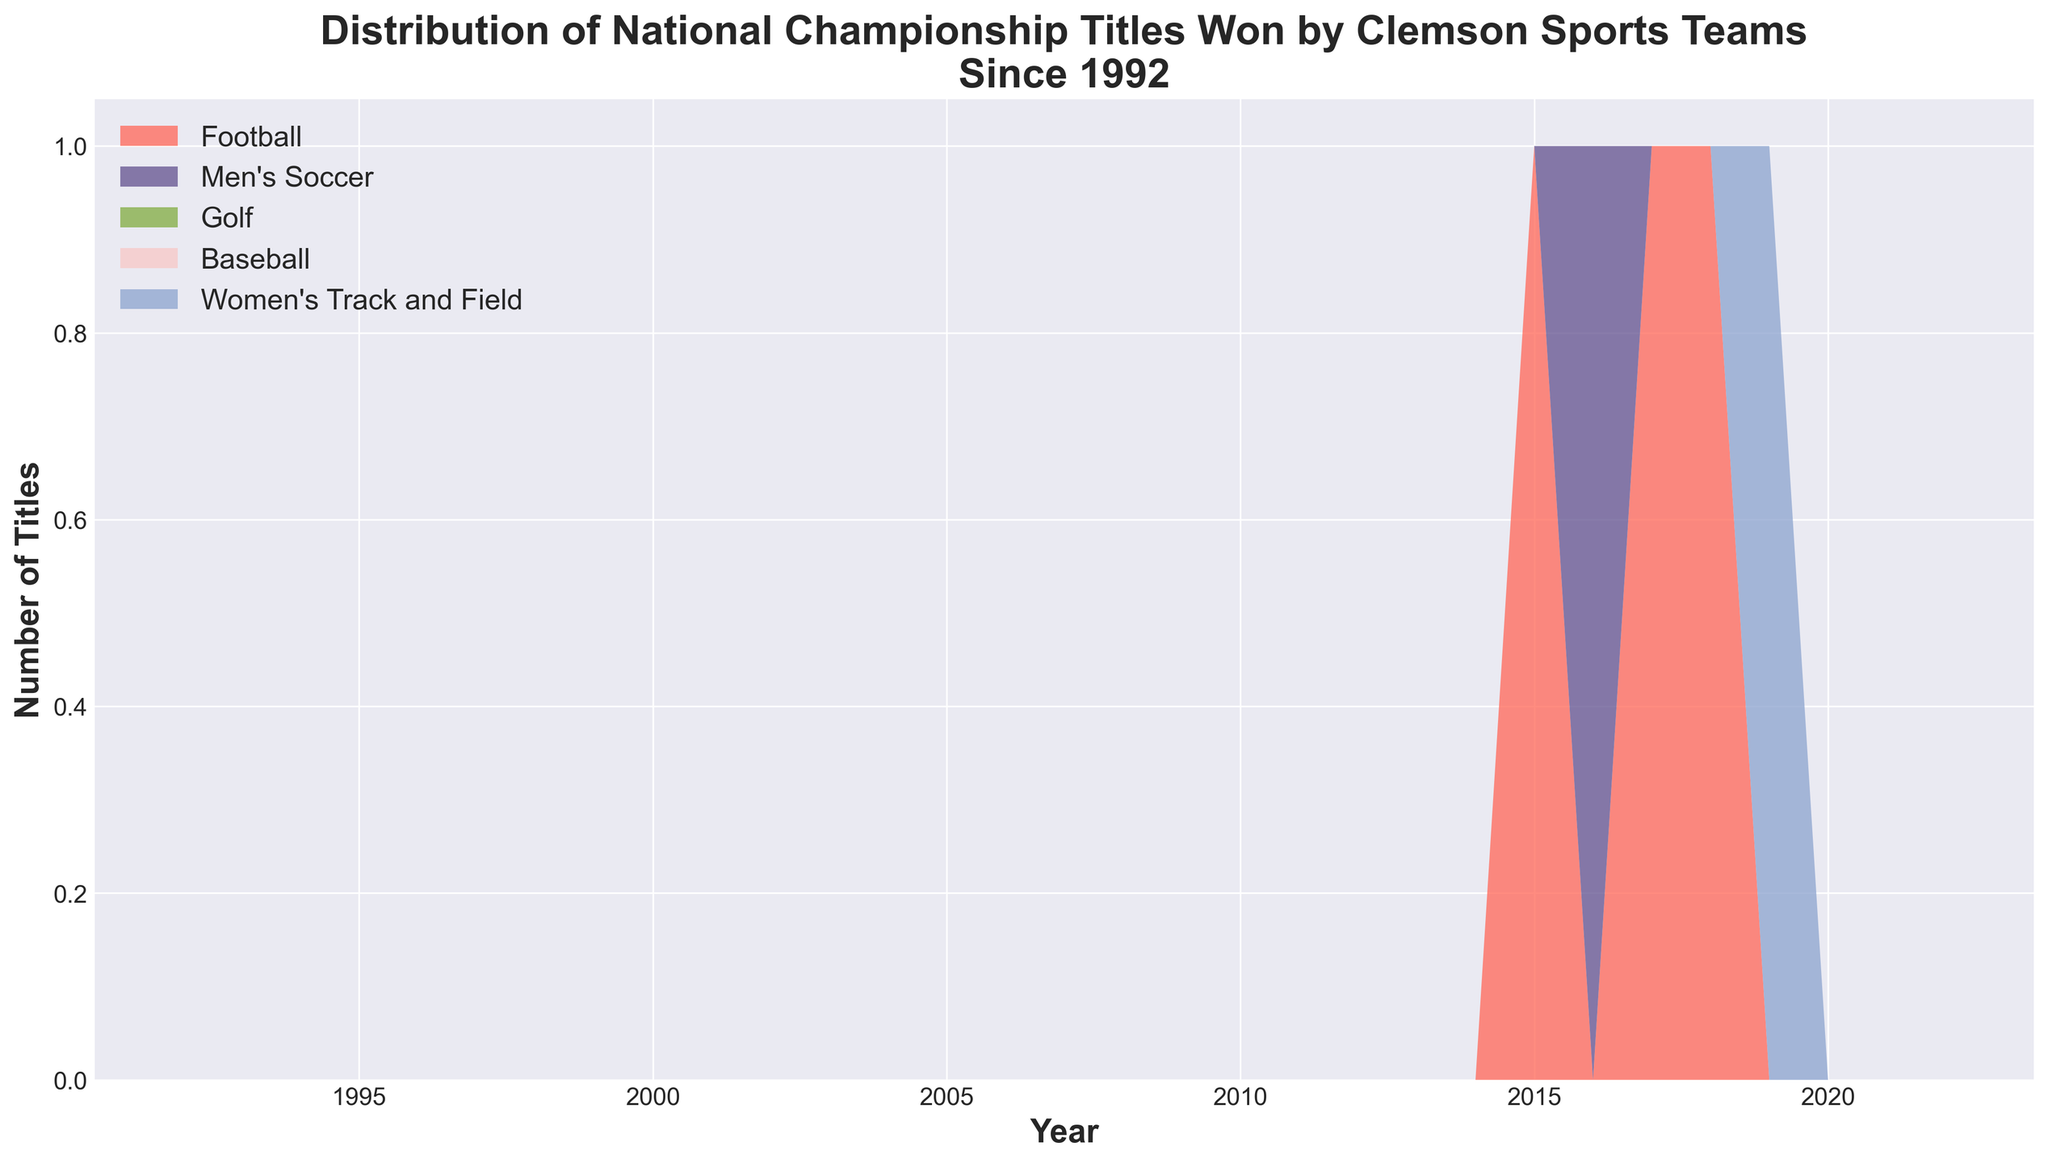Which sport has the highest number of championships in a single year? The chart shows the area sections for each sport and the value on the y-axis. The football area reaches the highest peak in 2015, 2017, and 2018.
Answer: Football How many total titles were won by Men's Soccer and Women's Track and Field combined? Look at the y-axis values for Men's Soccer in 2016 (1) and Women's Track and Field in 2019 (1). Add them together: 1 + 1 = 2.
Answer: 2 Which years did football win national championships? Identify the years where the region for football (red color) is above zero. The football area rises in 2015, 2017, and 2018.
Answer: 2015, 2017, 2018 Between 2015 and 2019, which sport had a championship each year? Check the plot areas within the 2015 to 2019 range. There are continuous titles for football only in 2015, 2017, and 2018; the other sports have only one title each during this period.
Answer: Football How many championships in total did Clemson sports teams win from 1992 to 2022? Calculate the total by summing up all the individual sports' values on the y-axis at every title year. (Football: 3, Men's Soccer: 1, Women's Track and Field: 1. Total: 3 + 1 + 1 = 5)
Answer: 5 Which sport won the last national championship title shown in the chart? The highest year with area above zero at the far right is 2019 for Women's Track and Field.
Answer: Women's Track and Field How many years did Clemson not win any national championship titles from 1992 to 2022? Identify the years where the entire area plot is zero. From 1992 to 2014 (inclusive), and 2016, 2019-2022 (inclusive) sum up to 27 years.
Answer: 27 What is the difference in the number of titles won by Football and Men's Soccer? Football won 3 titles (2015, 2017, 2018), and Men's Soccer won 1 title (2016). Difference: 3 - 1 = 2.
Answer: 2 Which two sports won a national championship title in consecutive years? Examine each area. Football won in 2015, Men's Soccer in 2016, Football in 2017, Football in 2018, and Women's Track and Field in 2019. Football and Men's Soccer won in consecutive years 2015-2017.
Answer: Football and Men's Soccer 